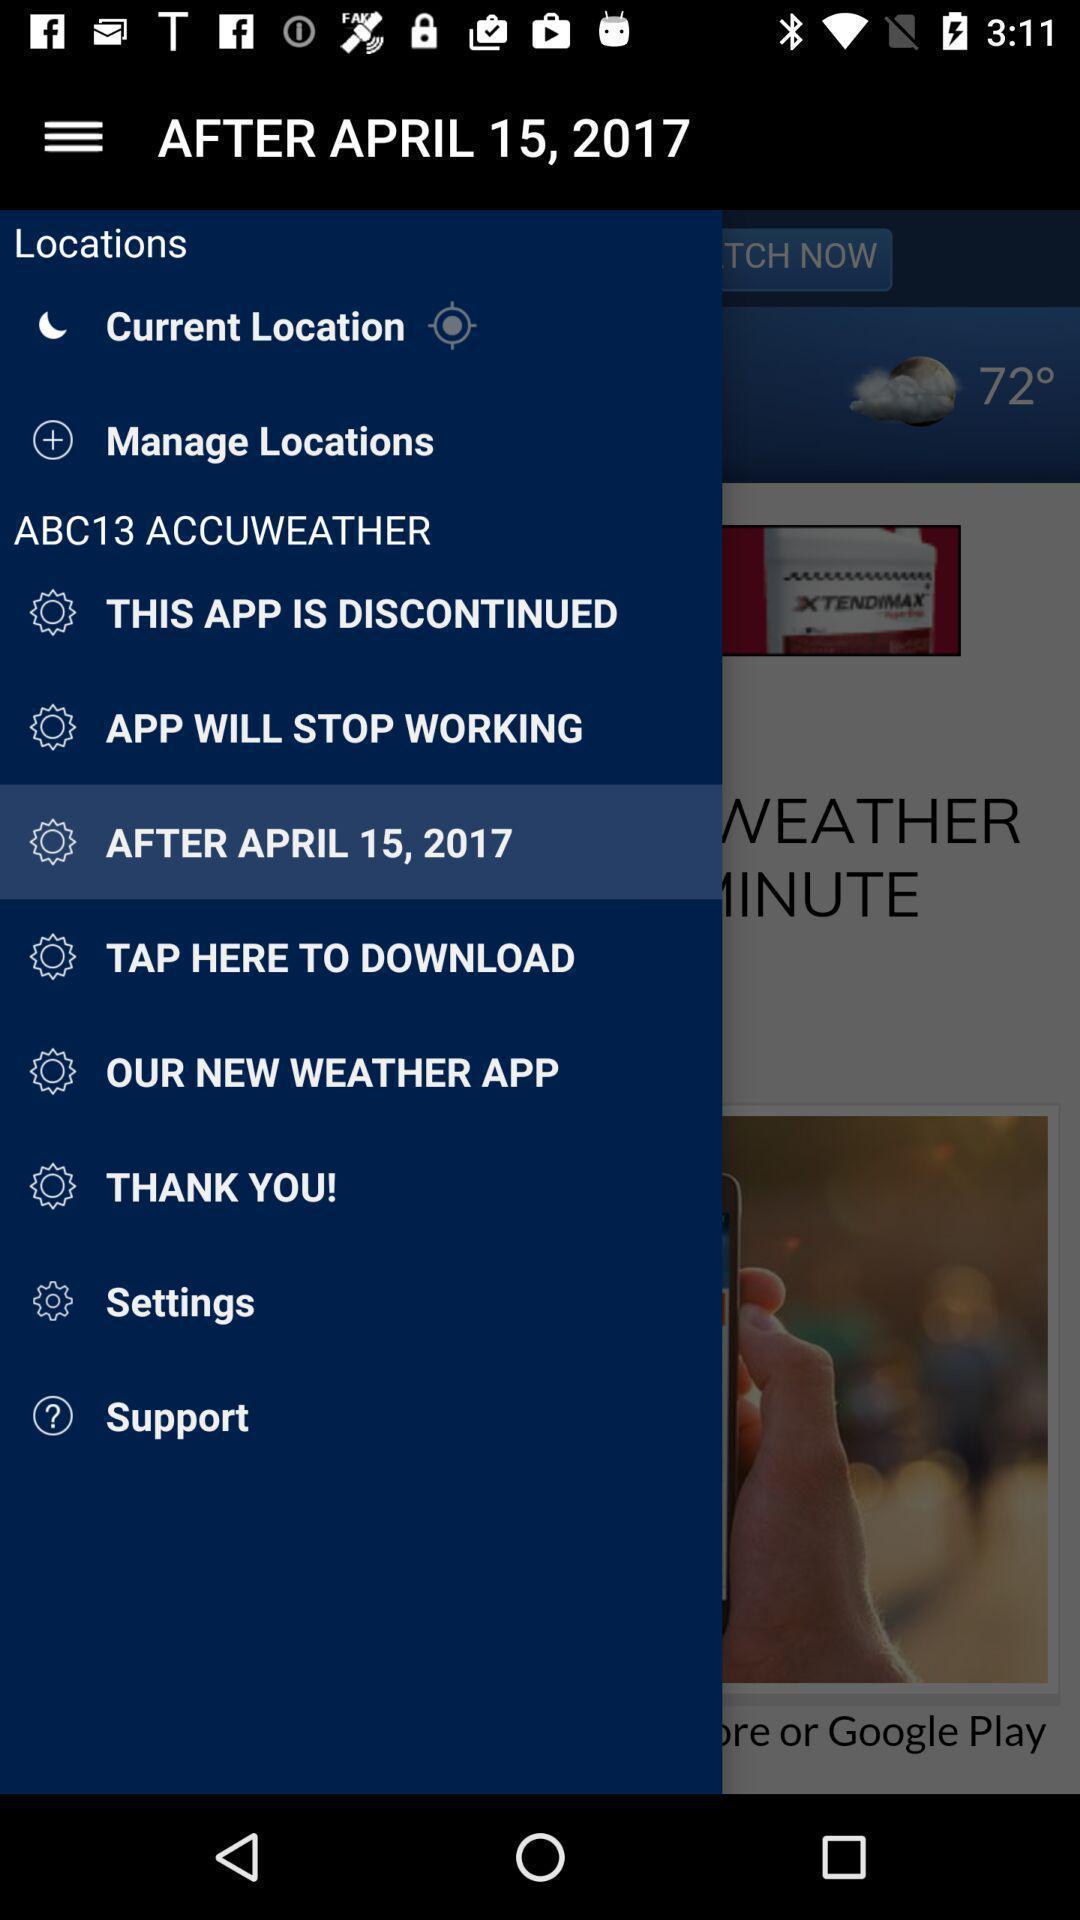Provide a textual representation of this image. Window displaying a weather app. 